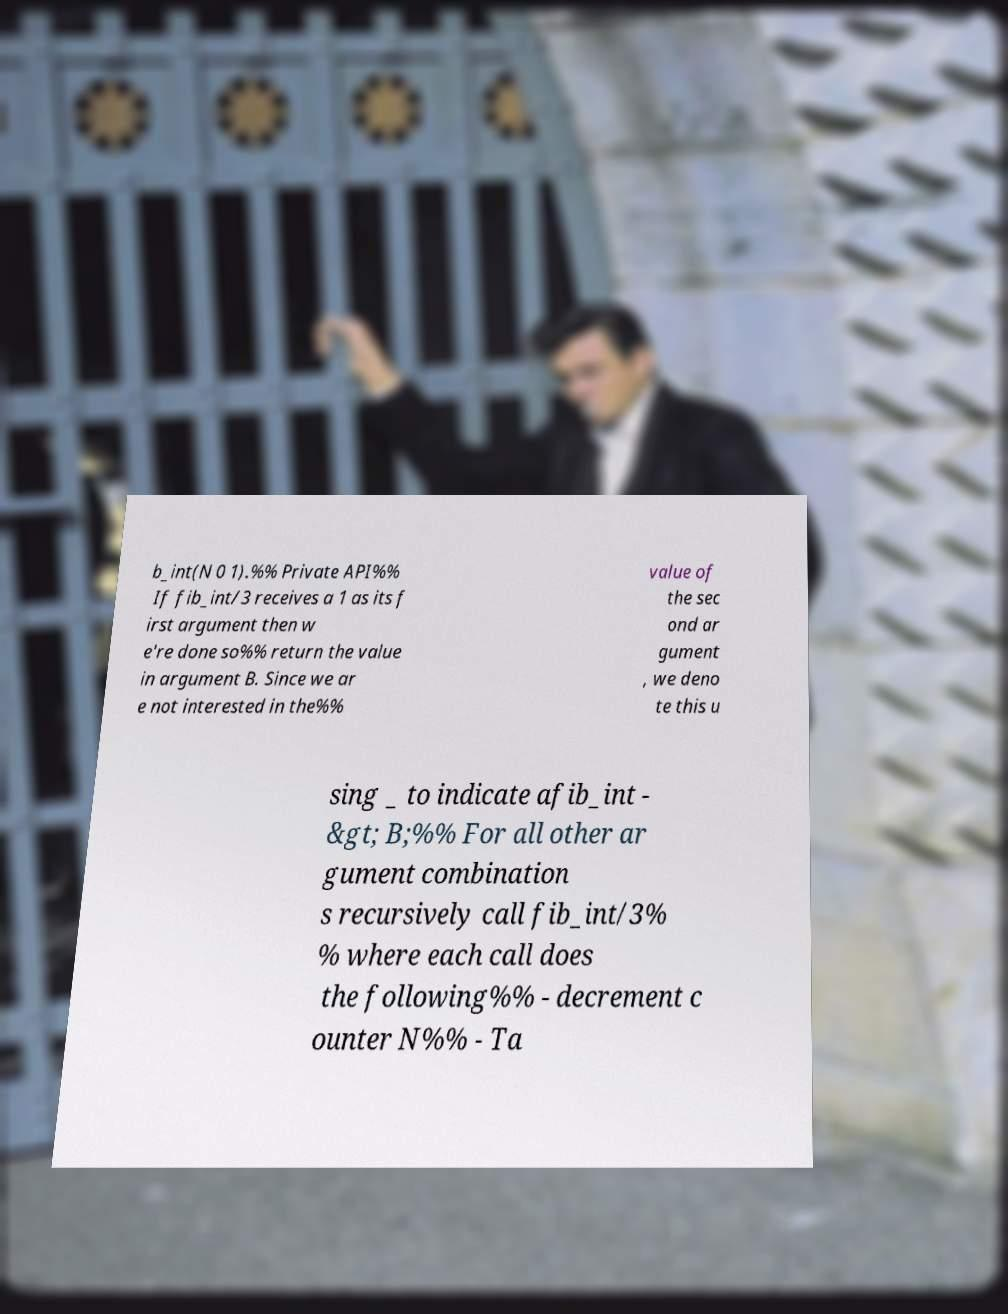Can you read and provide the text displayed in the image?This photo seems to have some interesting text. Can you extract and type it out for me? b_int(N 0 1).%% Private API%% If fib_int/3 receives a 1 as its f irst argument then w e're done so%% return the value in argument B. Since we ar e not interested in the%% value of the sec ond ar gument , we deno te this u sing _ to indicate afib_int - &gt; B;%% For all other ar gument combination s recursively call fib_int/3% % where each call does the following%% - decrement c ounter N%% - Ta 